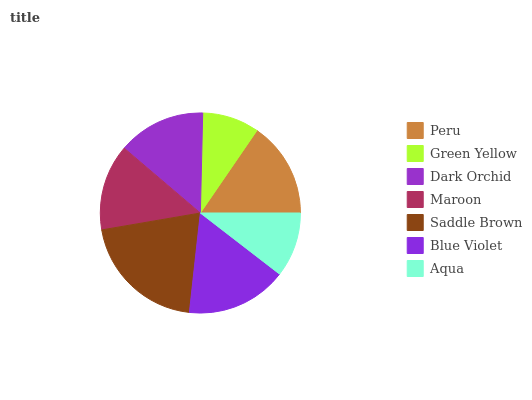Is Green Yellow the minimum?
Answer yes or no. Yes. Is Saddle Brown the maximum?
Answer yes or no. Yes. Is Dark Orchid the minimum?
Answer yes or no. No. Is Dark Orchid the maximum?
Answer yes or no. No. Is Dark Orchid greater than Green Yellow?
Answer yes or no. Yes. Is Green Yellow less than Dark Orchid?
Answer yes or no. Yes. Is Green Yellow greater than Dark Orchid?
Answer yes or no. No. Is Dark Orchid less than Green Yellow?
Answer yes or no. No. Is Dark Orchid the high median?
Answer yes or no. Yes. Is Dark Orchid the low median?
Answer yes or no. Yes. Is Blue Violet the high median?
Answer yes or no. No. Is Maroon the low median?
Answer yes or no. No. 